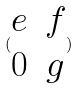<formula> <loc_0><loc_0><loc_500><loc_500>( \begin{matrix} e & f \\ 0 & g \end{matrix} )</formula> 